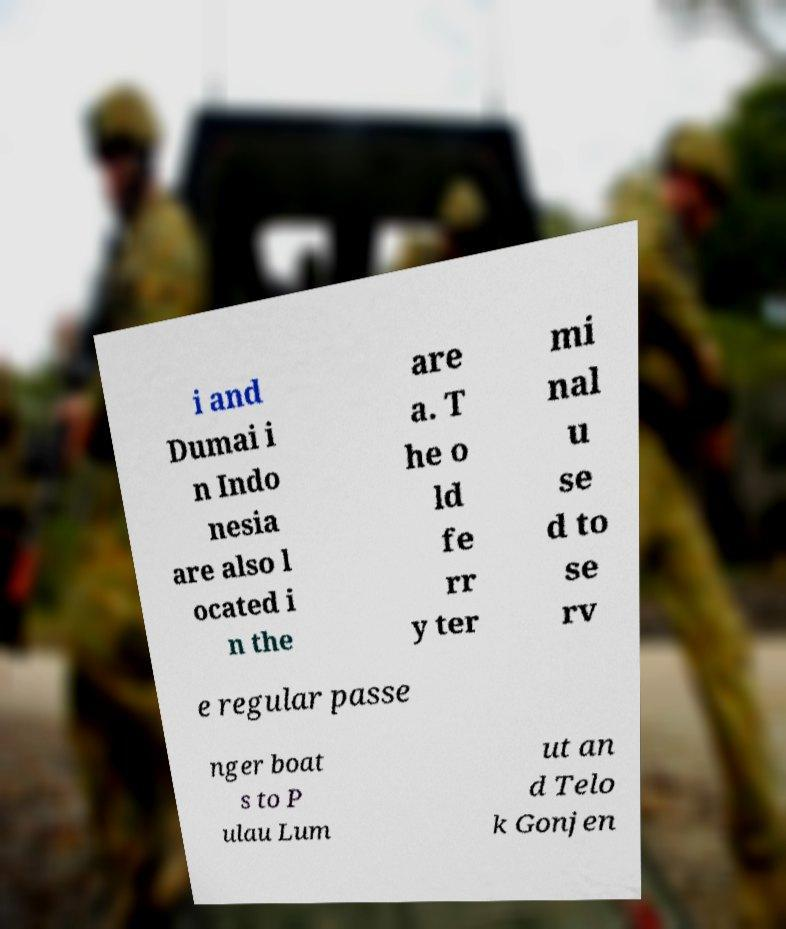What messages or text are displayed in this image? I need them in a readable, typed format. i and Dumai i n Indo nesia are also l ocated i n the are a. T he o ld fe rr y ter mi nal u se d to se rv e regular passe nger boat s to P ulau Lum ut an d Telo k Gonjen 